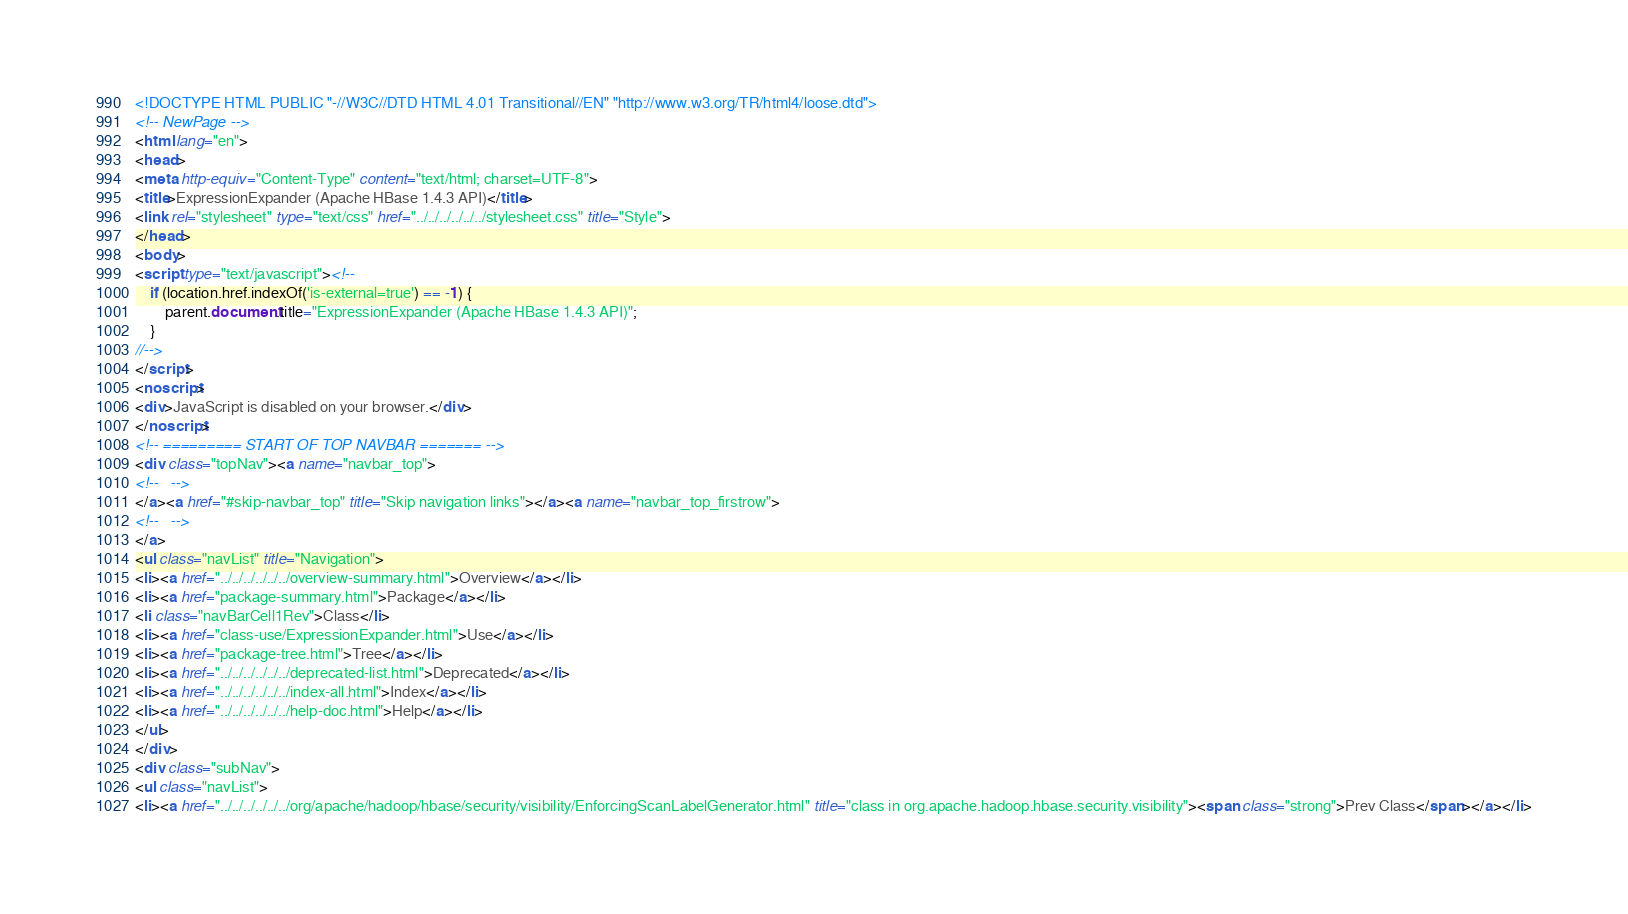Convert code to text. <code><loc_0><loc_0><loc_500><loc_500><_HTML_><!DOCTYPE HTML PUBLIC "-//W3C//DTD HTML 4.01 Transitional//EN" "http://www.w3.org/TR/html4/loose.dtd">
<!-- NewPage -->
<html lang="en">
<head>
<meta http-equiv="Content-Type" content="text/html; charset=UTF-8">
<title>ExpressionExpander (Apache HBase 1.4.3 API)</title>
<link rel="stylesheet" type="text/css" href="../../../../../../stylesheet.css" title="Style">
</head>
<body>
<script type="text/javascript"><!--
    if (location.href.indexOf('is-external=true') == -1) {
        parent.document.title="ExpressionExpander (Apache HBase 1.4.3 API)";
    }
//-->
</script>
<noscript>
<div>JavaScript is disabled on your browser.</div>
</noscript>
<!-- ========= START OF TOP NAVBAR ======= -->
<div class="topNav"><a name="navbar_top">
<!--   -->
</a><a href="#skip-navbar_top" title="Skip navigation links"></a><a name="navbar_top_firstrow">
<!--   -->
</a>
<ul class="navList" title="Navigation">
<li><a href="../../../../../../overview-summary.html">Overview</a></li>
<li><a href="package-summary.html">Package</a></li>
<li class="navBarCell1Rev">Class</li>
<li><a href="class-use/ExpressionExpander.html">Use</a></li>
<li><a href="package-tree.html">Tree</a></li>
<li><a href="../../../../../../deprecated-list.html">Deprecated</a></li>
<li><a href="../../../../../../index-all.html">Index</a></li>
<li><a href="../../../../../../help-doc.html">Help</a></li>
</ul>
</div>
<div class="subNav">
<ul class="navList">
<li><a href="../../../../../../org/apache/hadoop/hbase/security/visibility/EnforcingScanLabelGenerator.html" title="class in org.apache.hadoop.hbase.security.visibility"><span class="strong">Prev Class</span></a></li></code> 